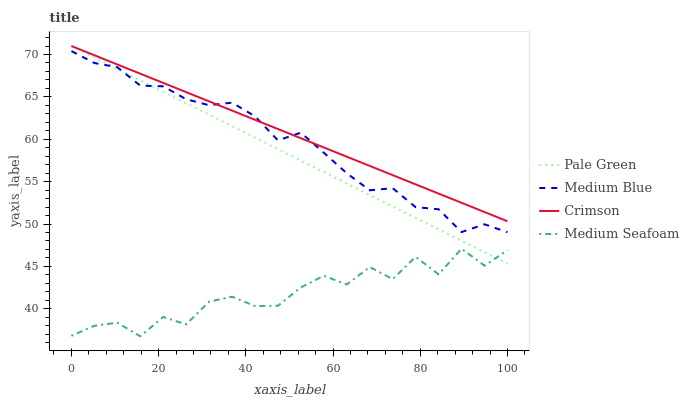Does Medium Seafoam have the minimum area under the curve?
Answer yes or no. Yes. Does Crimson have the maximum area under the curve?
Answer yes or no. Yes. Does Pale Green have the minimum area under the curve?
Answer yes or no. No. Does Pale Green have the maximum area under the curve?
Answer yes or no. No. Is Pale Green the smoothest?
Answer yes or no. Yes. Is Medium Seafoam the roughest?
Answer yes or no. Yes. Is Medium Blue the smoothest?
Answer yes or no. No. Is Medium Blue the roughest?
Answer yes or no. No. Does Medium Seafoam have the lowest value?
Answer yes or no. Yes. Does Pale Green have the lowest value?
Answer yes or no. No. Does Pale Green have the highest value?
Answer yes or no. Yes. Does Medium Blue have the highest value?
Answer yes or no. No. Is Medium Seafoam less than Medium Blue?
Answer yes or no. Yes. Is Medium Blue greater than Medium Seafoam?
Answer yes or no. Yes. Does Pale Green intersect Medium Blue?
Answer yes or no. Yes. Is Pale Green less than Medium Blue?
Answer yes or no. No. Is Pale Green greater than Medium Blue?
Answer yes or no. No. Does Medium Seafoam intersect Medium Blue?
Answer yes or no. No. 